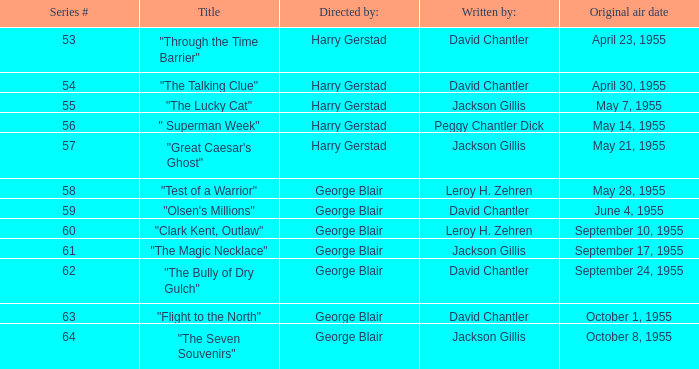What is the lowest number of series? 53.0. 